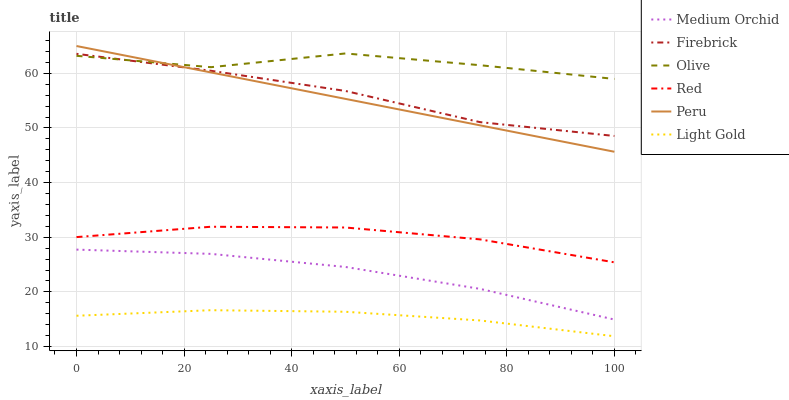Does Light Gold have the minimum area under the curve?
Answer yes or no. Yes. Does Olive have the maximum area under the curve?
Answer yes or no. Yes. Does Medium Orchid have the minimum area under the curve?
Answer yes or no. No. Does Medium Orchid have the maximum area under the curve?
Answer yes or no. No. Is Peru the smoothest?
Answer yes or no. Yes. Is Olive the roughest?
Answer yes or no. Yes. Is Medium Orchid the smoothest?
Answer yes or no. No. Is Medium Orchid the roughest?
Answer yes or no. No. Does Light Gold have the lowest value?
Answer yes or no. Yes. Does Medium Orchid have the lowest value?
Answer yes or no. No. Does Peru have the highest value?
Answer yes or no. Yes. Does Medium Orchid have the highest value?
Answer yes or no. No. Is Light Gold less than Olive?
Answer yes or no. Yes. Is Peru greater than Red?
Answer yes or no. Yes. Does Firebrick intersect Peru?
Answer yes or no. Yes. Is Firebrick less than Peru?
Answer yes or no. No. Is Firebrick greater than Peru?
Answer yes or no. No. Does Light Gold intersect Olive?
Answer yes or no. No. 